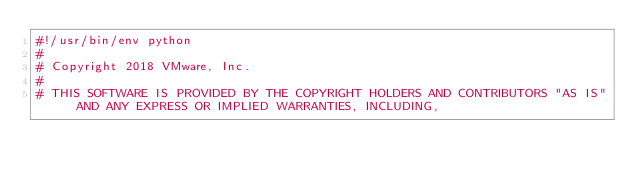<code> <loc_0><loc_0><loc_500><loc_500><_Python_>#!/usr/bin/env python
#
# Copyright 2018 VMware, Inc.
#
# THIS SOFTWARE IS PROVIDED BY THE COPYRIGHT HOLDERS AND CONTRIBUTORS "AS IS" AND ANY EXPRESS OR IMPLIED WARRANTIES, INCLUDING,</code> 